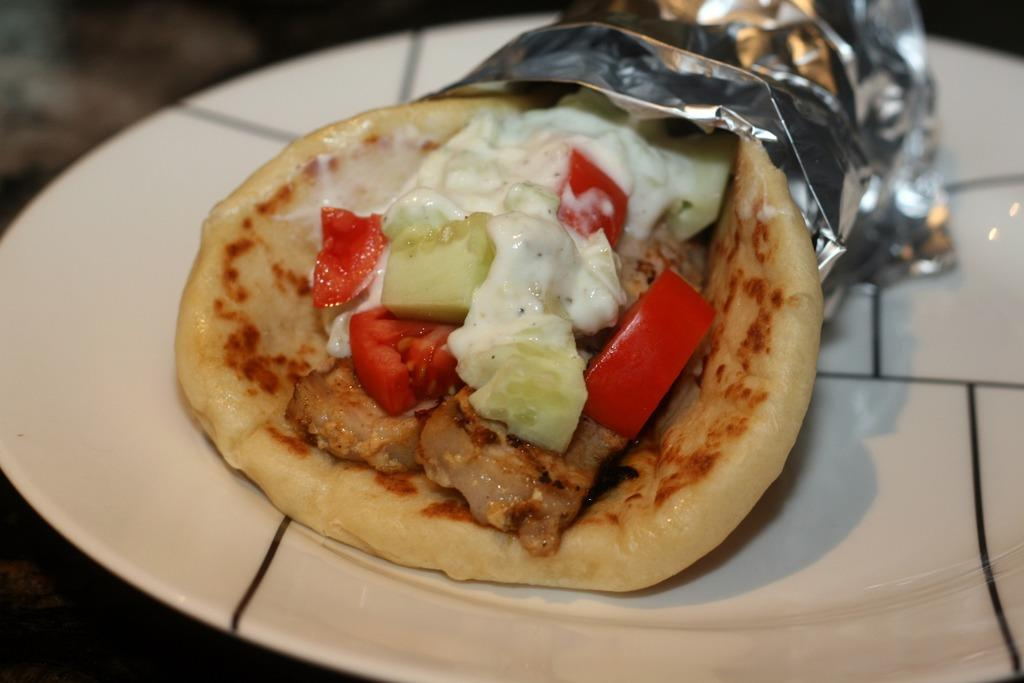What is present in the image related to food? There is food in the image. Can you describe the appearance of the food in the image? The food is on a plate with silver paper. What type of island can be seen in the background of the image? There is no island present in the image. Who is the minister in the image? There is no minister present in the image. What type of wine is being served with the food in the image? There is no wine present in the image. 